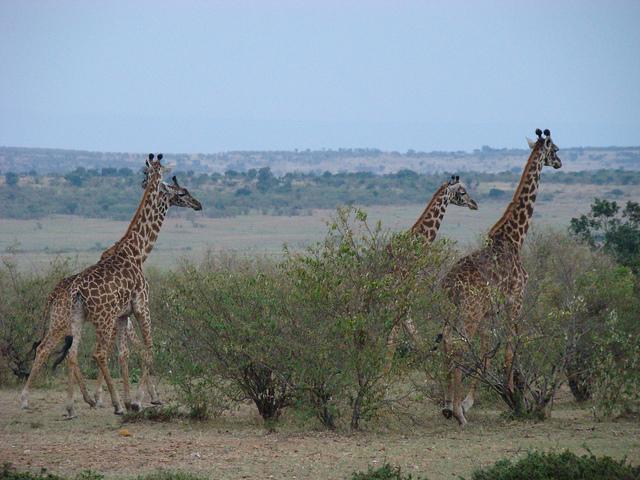Does the animal appear to be in captivity?
Give a very brief answer. No. How many animals?
Write a very short answer. 3. How many animals are grazing?
Quick response, please. 4. Would you say it is midday?
Quick response, please. Yes. Are the giraffes running?
Keep it brief. Yes. Can this animal have two heads?
Keep it brief. No. Is this photo taken in the wild?
Keep it brief. Yes. 